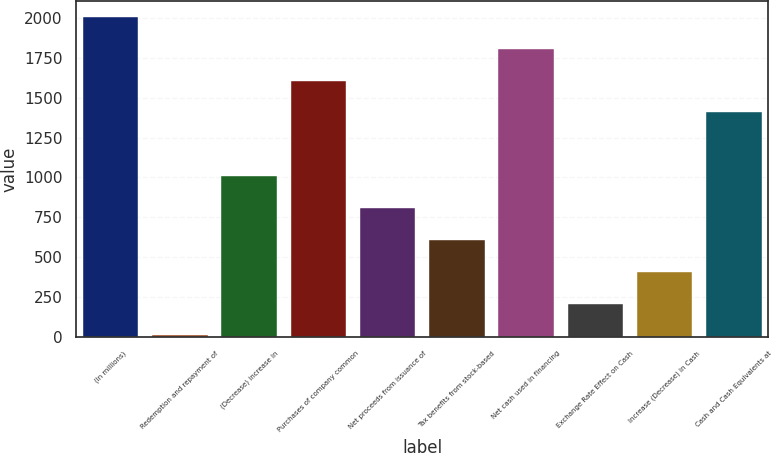Convert chart to OTSL. <chart><loc_0><loc_0><loc_500><loc_500><bar_chart><fcel>(In millions)<fcel>Redemption and repayment of<fcel>(Decrease) increase in<fcel>Purchases of company common<fcel>Net proceeds from issuance of<fcel>Tax benefits from stock-based<fcel>Net cash used in financing<fcel>Exchange Rate Effect on Cash<fcel>Increase (Decrease) in Cash<fcel>Cash and Cash Equivalents at<nl><fcel>2007<fcel>9.4<fcel>1008.2<fcel>1607.48<fcel>808.44<fcel>608.68<fcel>1807.24<fcel>209.16<fcel>408.92<fcel>1407.72<nl></chart> 